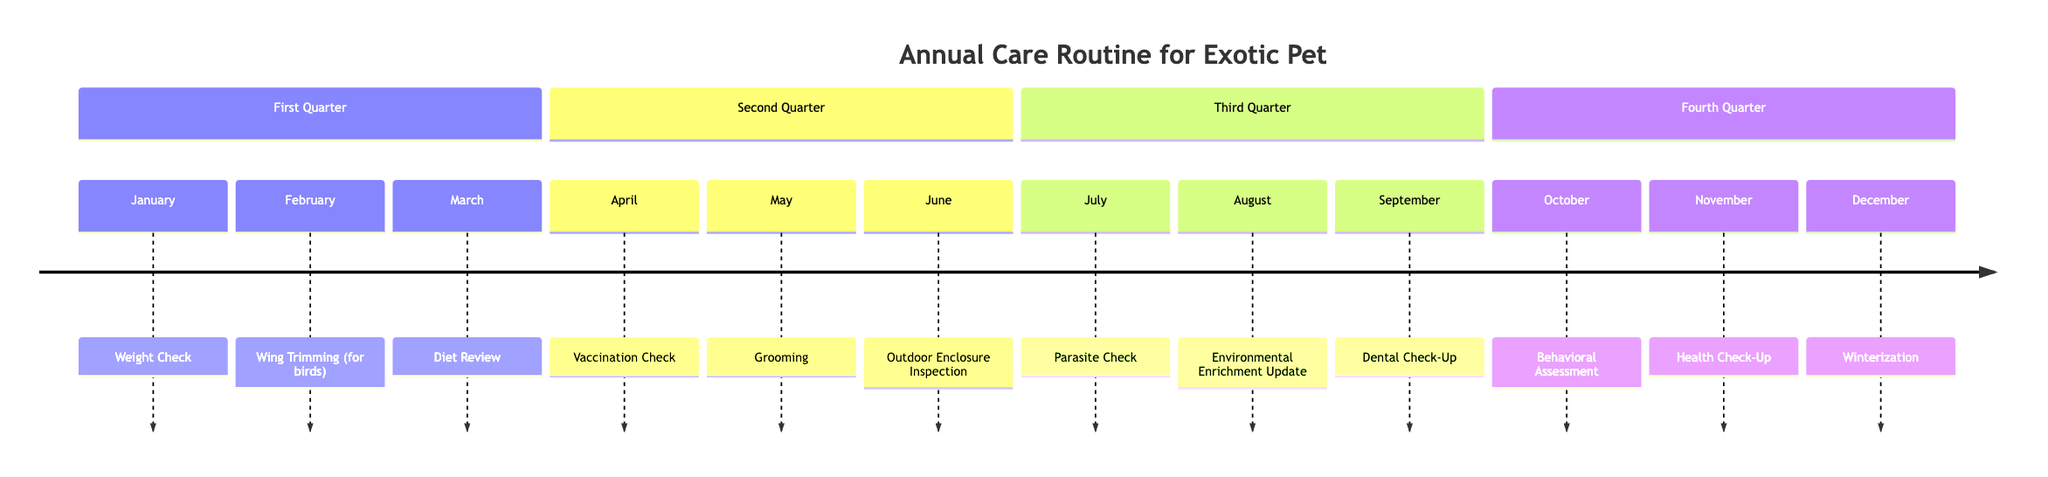What activity is scheduled for January? The diagram indicates that the activity planned for January is a Weight Check. This information is clearly labeled at the start of the timeline.
Answer: Weight Check How many activities are listed for the Second Quarter? The Second Quarter of the timeline contains three activities: Vaccination Check, Grooming, and Outdoor Enclosure Inspection. Counting these gives a total of three activities.
Answer: 3 What is the focus of the activity in August? According to the diagram, the activity scheduled for August is an Environmental Enrichment Update. This indicates the focus is on providing stimulation for the pet.
Answer: Environmental Enrichment Update Which month has a Health Check-Up? The diagram specifies that a Health Check-Up takes place in November. This is clearly denoted in that month section.
Answer: November What are the key activities in the Third Quarter? The Third Quarter includes three activities: Parasite Check in July, Environmental Enrichment Update in August, and Dental Check-Up in September. These can be found listed in that section.
Answer: Parasite Check, Environmental Enrichment Update, Dental Check-Up Which activity follows the Dental Check-Up? The diagram shows that after the Dental Check-Up in September, the next activity scheduled is the Behavioral Assessment in October. This flows directly in the timeline.
Answer: Behavioral Assessment What is the last activity of the year? The diagram indicates that the last scheduled activity of the year is Winterization, which takes place in December. This is at the end of the timeline.
Answer: Winterization Which activity occurs in April? The timeline states that the activity in April is a Vaccination Check, as specified clearly for that month.
Answer: Vaccination Check What is the relationship between the activities in March and April? The activities in March (Diet Review) and April (Vaccination Check) are consecutive in the timeline, with Diet Review happening first and followed directly by Vaccination Check.
Answer: Consecutive activities 